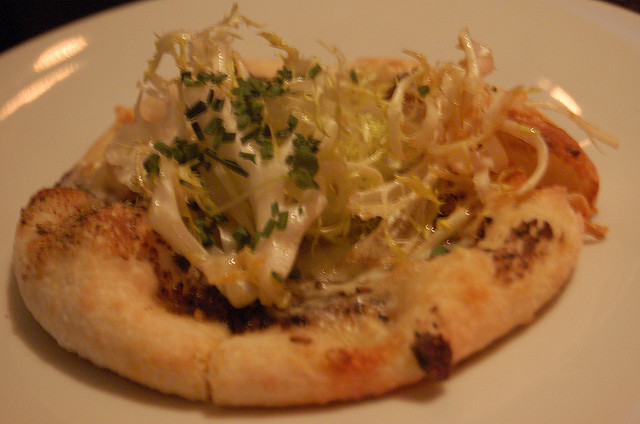<image>What kind of sauce is on this food? I am not sure what kind of sauce is on the food. It could be horseradish, white sauce, tomato, alfredo, or pizza sauce. What kind of sauce is on this food? I am not sure what kind of sauce is on the food. It could be horseradish, white sauce, tomato, alfredo, or something unknown. 